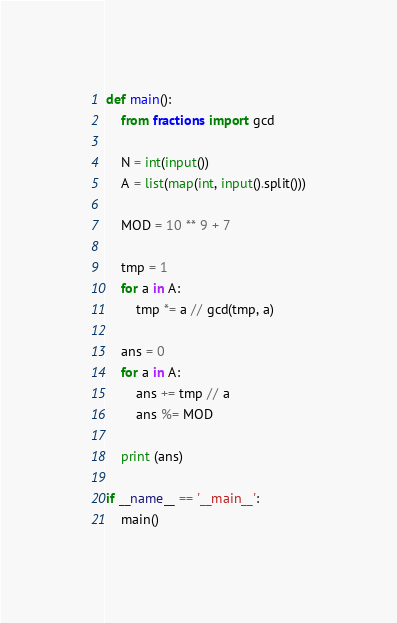<code> <loc_0><loc_0><loc_500><loc_500><_Python_>def main():
    from fractions import gcd

    N = int(input())
    A = list(map(int, input().split()))

    MOD = 10 ** 9 + 7

    tmp = 1
    for a in A:
        tmp *= a // gcd(tmp, a)

    ans = 0
    for a in A:
        ans += tmp // a
        ans %= MOD

    print (ans)

if __name__ == '__main__':
    main()</code> 